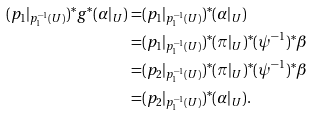<formula> <loc_0><loc_0><loc_500><loc_500>( p _ { 1 } | _ { p _ { 1 } ^ { - 1 } ( U ) } ) ^ { * } g ^ { * } ( \alpha | _ { U } ) = & ( p _ { 1 } | _ { p _ { 1 } ^ { - 1 } ( U ) } ) ^ { * } ( \alpha | _ { U } ) \\ = & ( p _ { 1 } | _ { p _ { 1 } ^ { - 1 } ( U ) } ) ^ { * } ( \pi | _ { U } ) ^ { * } ( \psi ^ { - 1 } ) ^ { * } \beta \\ = & ( p _ { 2 } | _ { p _ { 1 } ^ { - 1 } ( U ) } ) ^ { * } ( \pi | _ { U } ) ^ { * } ( \psi ^ { - 1 } ) ^ { * } \beta \\ = & ( p _ { 2 } | _ { p _ { 1 } ^ { - 1 } ( U ) } ) ^ { * } ( \alpha | _ { U } ) .</formula> 